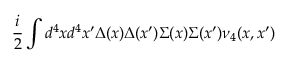<formula> <loc_0><loc_0><loc_500><loc_500>\frac { i } { 2 } \int d ^ { 4 } x d ^ { 4 } x ^ { \prime } \Delta ( x ) \Delta ( x ^ { \prime } ) \Sigma ( x ) \Sigma ( x ^ { \prime } ) \nu _ { 4 } ( x , x ^ { \prime } )</formula> 